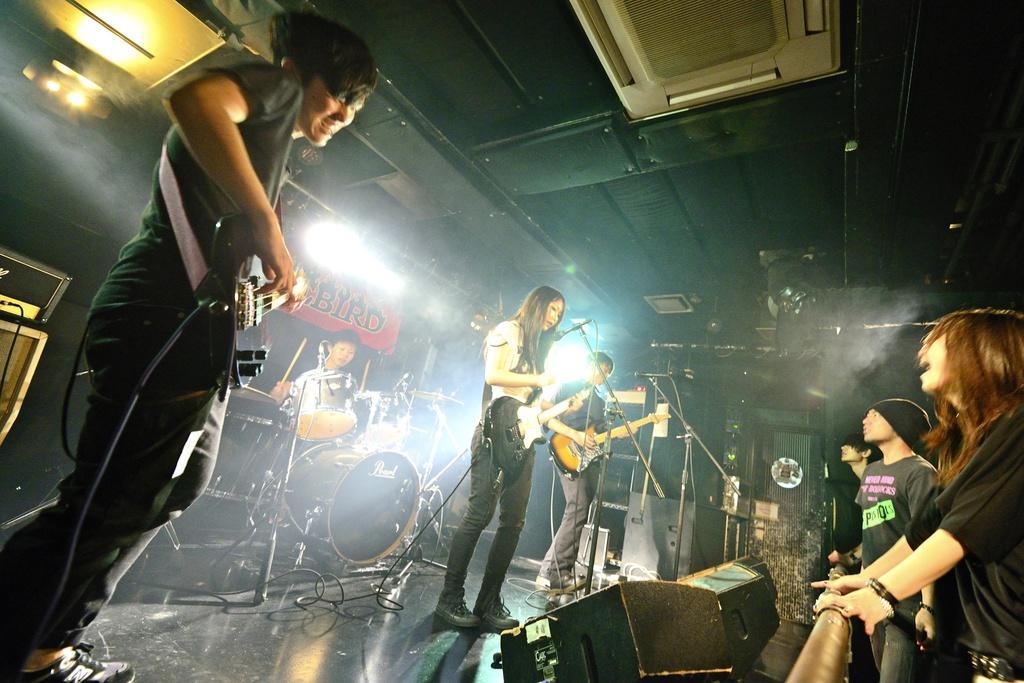Could you give a brief overview of what you see in this image? This picture is clicked at a concert. There are four musicians on the dais. Three of them are playing acoustic guitars and the other man is playing drums. On the floor there are boxes, microphones, stands, drums, drum stands and cables. At the right corner of the image there are spectators. In the background there is banner with text, wall and lights.  